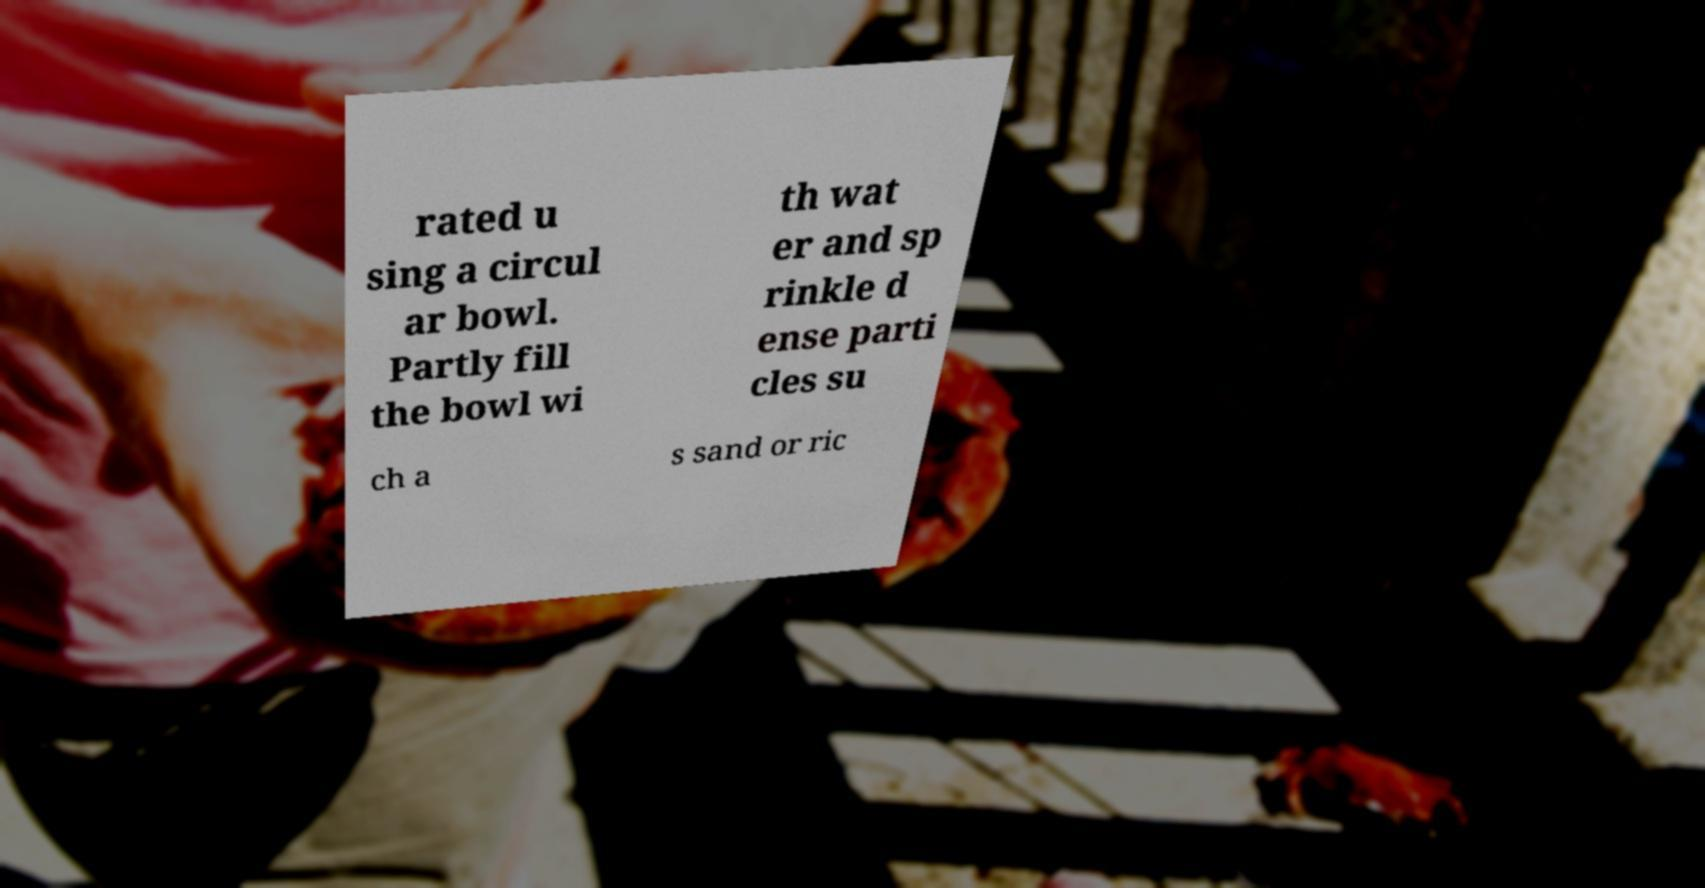Can you read and provide the text displayed in the image?This photo seems to have some interesting text. Can you extract and type it out for me? rated u sing a circul ar bowl. Partly fill the bowl wi th wat er and sp rinkle d ense parti cles su ch a s sand or ric 